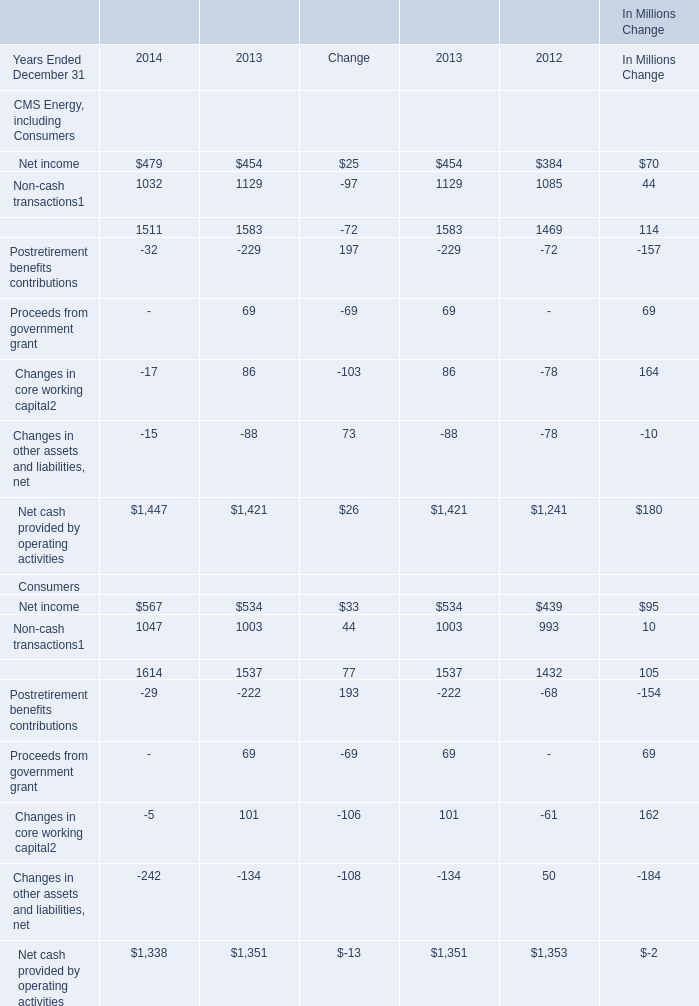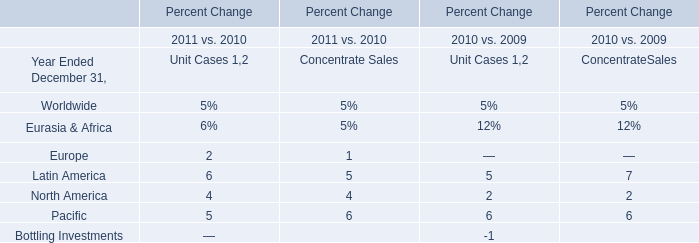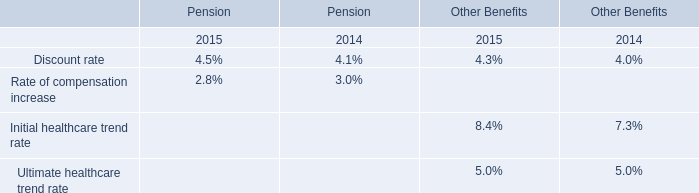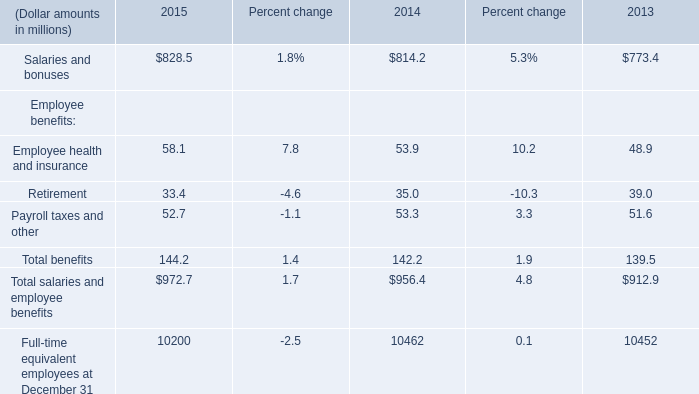What is the total value of Net income, Non-cash transactions, Postretirement benefits contributions and Changes in core working capital of Consumers in 2014? (in million) 
Computations: (((567 + 1047) + -29) + -5)
Answer: 1580.0. 